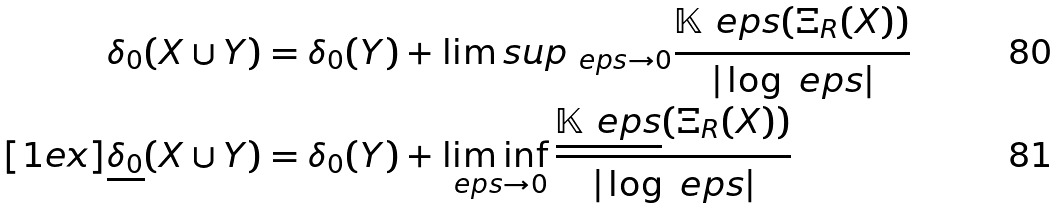<formula> <loc_0><loc_0><loc_500><loc_500>\delta _ { 0 } ( X \cup Y ) & = \delta _ { 0 } ( Y ) + \lim s u p _ { \ e p s \to 0 } \frac { { \mathbb { K } } _ { \ } e p s ( \Xi _ { R } ( X ) ) } { | \log \ e p s | } \\ [ 1 e x ] \underline { \delta _ { 0 } } ( X \cup Y ) & = \delta _ { 0 } ( Y ) + \liminf _ { \ e p s \to 0 } \frac { \underline { { \mathbb { K } } _ { \ } e p s } ( \Xi _ { R } ( X ) ) } { | \log \ e p s | }</formula> 